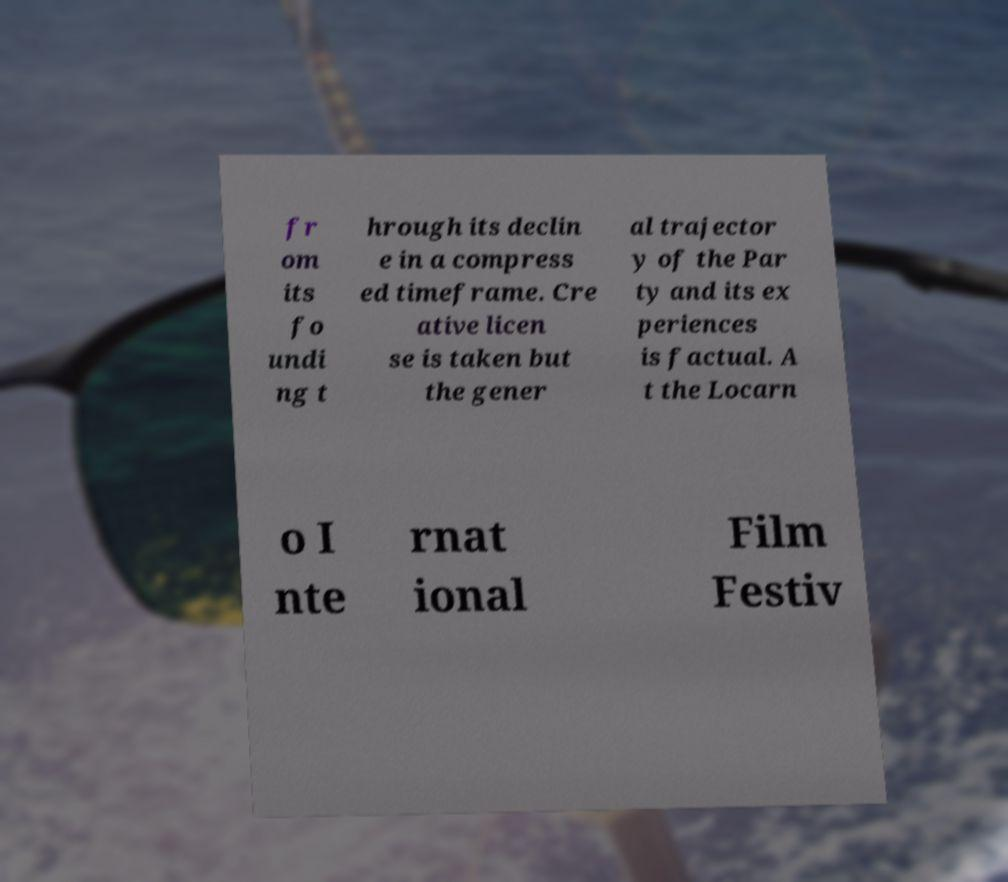Can you read and provide the text displayed in the image?This photo seems to have some interesting text. Can you extract and type it out for me? fr om its fo undi ng t hrough its declin e in a compress ed timeframe. Cre ative licen se is taken but the gener al trajector y of the Par ty and its ex periences is factual. A t the Locarn o I nte rnat ional Film Festiv 